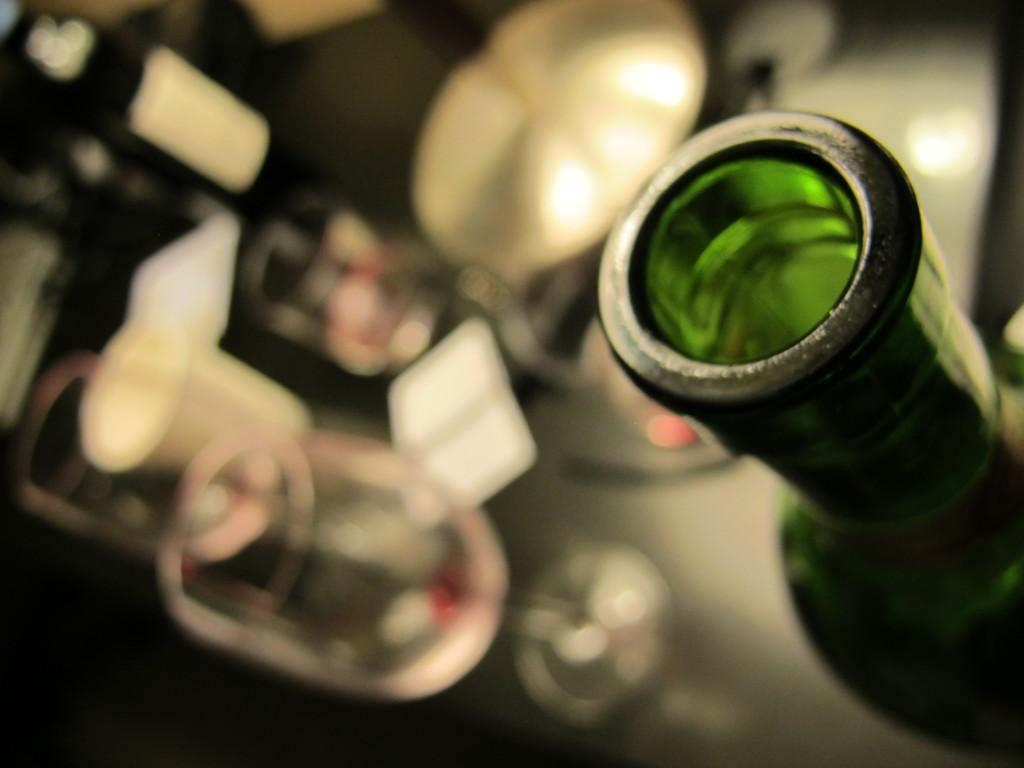What is present in the image that can hold liquids? There is a bottle in the image. What else can be seen in the image that can hold liquids? There are glasses in the image. What type of appliance is used to bake cookies in the image? There is no appliance or cookies present in the image. What machine is responsible for creating the glasses in the image? The glasses in the image are not created by a machine; they are separate objects. 